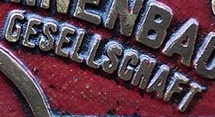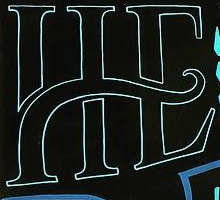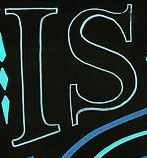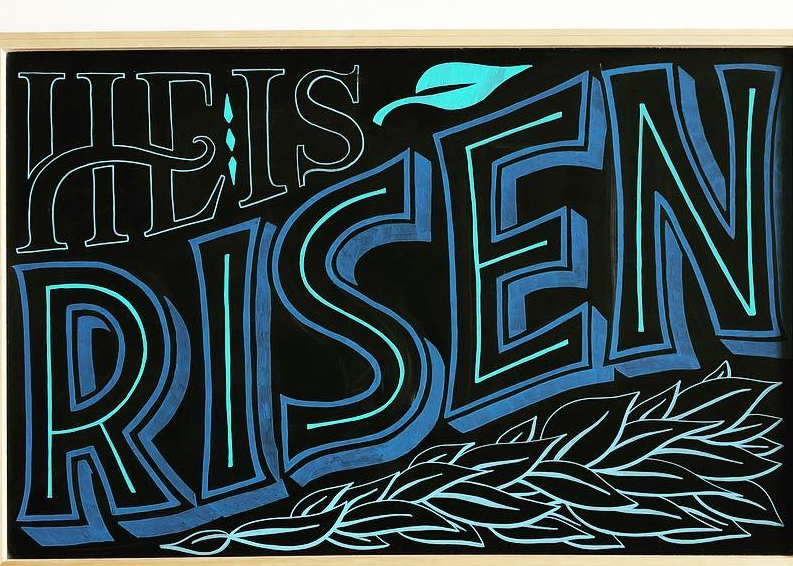What text appears in these images from left to right, separated by a semicolon? GESELLSGNAFT; HE; IS; RISEN 